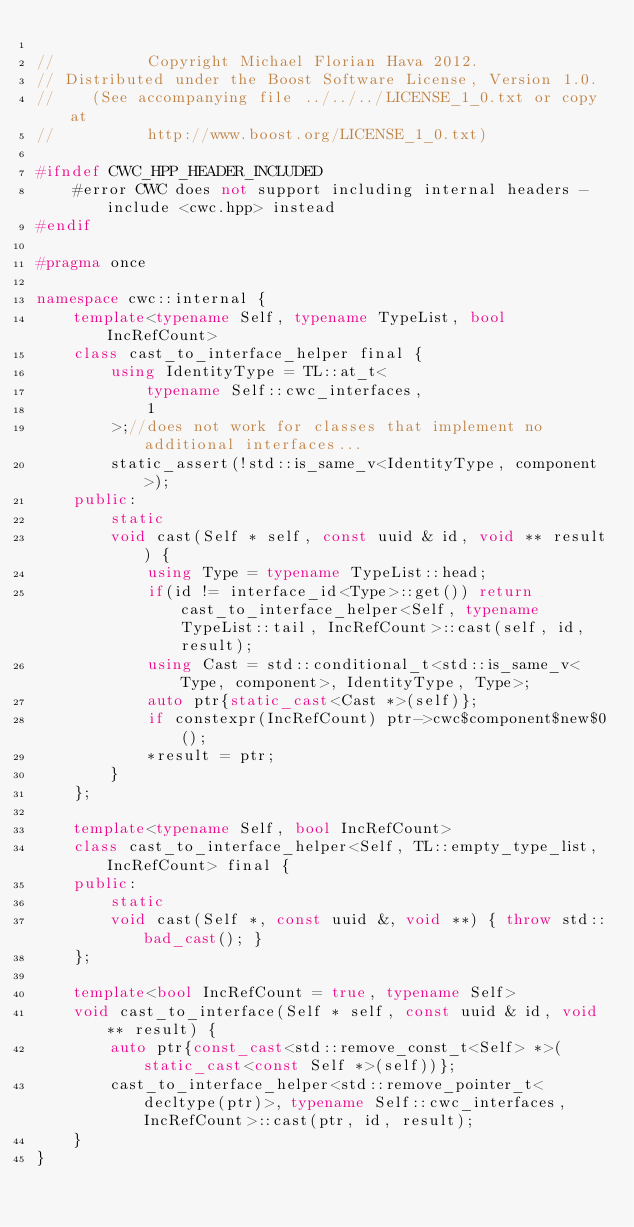Convert code to text. <code><loc_0><loc_0><loc_500><loc_500><_C++_>
//          Copyright Michael Florian Hava 2012.
// Distributed under the Boost Software License, Version 1.0.
//    (See accompanying file ../../../LICENSE_1_0.txt or copy at
//          http://www.boost.org/LICENSE_1_0.txt)

#ifndef CWC_HPP_HEADER_INCLUDED
	#error CWC does not support including internal headers - include <cwc.hpp> instead
#endif

#pragma once

namespace cwc::internal {
	template<typename Self, typename TypeList, bool IncRefCount>
	class cast_to_interface_helper final {
		using IdentityType = TL::at_t<
			typename Self::cwc_interfaces,
			1
		>;//does not work for classes that implement no additional interfaces...
		static_assert(!std::is_same_v<IdentityType, component>);
	public:
		static
		void cast(Self * self, const uuid & id, void ** result) {
			using Type = typename TypeList::head;
			if(id != interface_id<Type>::get()) return cast_to_interface_helper<Self, typename TypeList::tail, IncRefCount>::cast(self, id, result);
			using Cast = std::conditional_t<std::is_same_v<Type, component>, IdentityType, Type>;
			auto ptr{static_cast<Cast *>(self)};
			if constexpr(IncRefCount) ptr->cwc$component$new$0();
			*result = ptr;
		}
	};

	template<typename Self, bool IncRefCount>
	class cast_to_interface_helper<Self, TL::empty_type_list, IncRefCount> final {
	public:
		static
		void cast(Self *, const uuid &, void **) { throw std::bad_cast(); }
	};

	template<bool IncRefCount = true, typename Self>
	void cast_to_interface(Self * self, const uuid & id, void ** result) {
		auto ptr{const_cast<std::remove_const_t<Self> *>(static_cast<const Self *>(self))};
		cast_to_interface_helper<std::remove_pointer_t<decltype(ptr)>, typename Self::cwc_interfaces, IncRefCount>::cast(ptr, id, result);
	}
}
</code> 